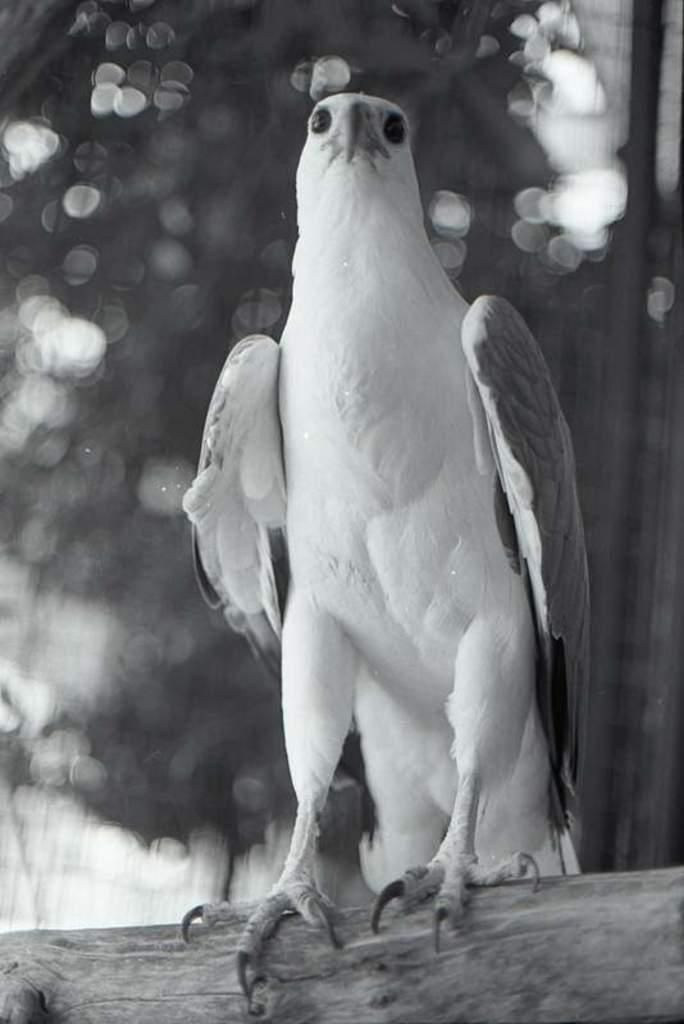What is the main subject of the black and white picture in the image? The main subject of the black and white picture in the image is a bird. Where is the bird located in the picture? The bird is on a wooden log. Can you describe the background of the image? The background of the image is blurred. What type of shoe is the bird wearing in the image? There is no shoe present in the image, as the bird is on a wooden log and not wearing any footwear. 